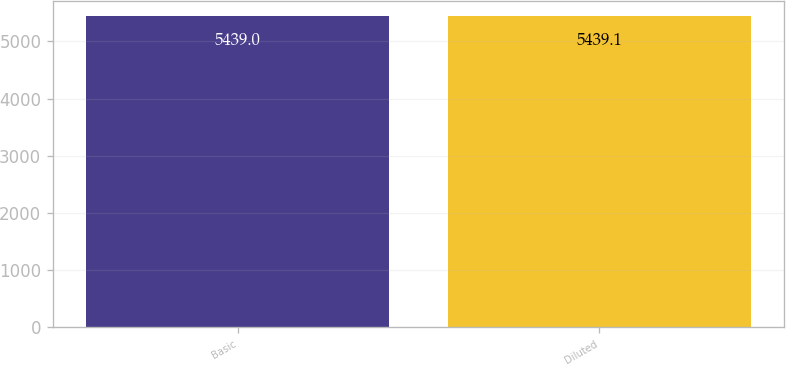Convert chart to OTSL. <chart><loc_0><loc_0><loc_500><loc_500><bar_chart><fcel>Basic<fcel>Diluted<nl><fcel>5439<fcel>5439.1<nl></chart> 